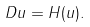Convert formula to latex. <formula><loc_0><loc_0><loc_500><loc_500>D u = H ( u ) .</formula> 